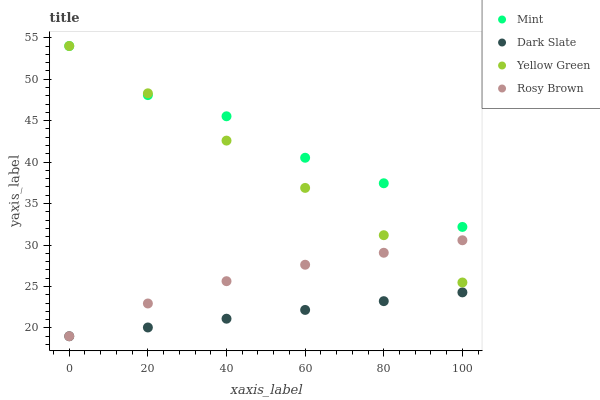Does Dark Slate have the minimum area under the curve?
Answer yes or no. Yes. Does Mint have the maximum area under the curve?
Answer yes or no. Yes. Does Rosy Brown have the minimum area under the curve?
Answer yes or no. No. Does Rosy Brown have the maximum area under the curve?
Answer yes or no. No. Is Dark Slate the smoothest?
Answer yes or no. Yes. Is Mint the roughest?
Answer yes or no. Yes. Is Rosy Brown the smoothest?
Answer yes or no. No. Is Rosy Brown the roughest?
Answer yes or no. No. Does Dark Slate have the lowest value?
Answer yes or no. Yes. Does Mint have the lowest value?
Answer yes or no. No. Does Yellow Green have the highest value?
Answer yes or no. Yes. Does Rosy Brown have the highest value?
Answer yes or no. No. Is Dark Slate less than Yellow Green?
Answer yes or no. Yes. Is Mint greater than Rosy Brown?
Answer yes or no. Yes. Does Dark Slate intersect Rosy Brown?
Answer yes or no. Yes. Is Dark Slate less than Rosy Brown?
Answer yes or no. No. Is Dark Slate greater than Rosy Brown?
Answer yes or no. No. Does Dark Slate intersect Yellow Green?
Answer yes or no. No. 